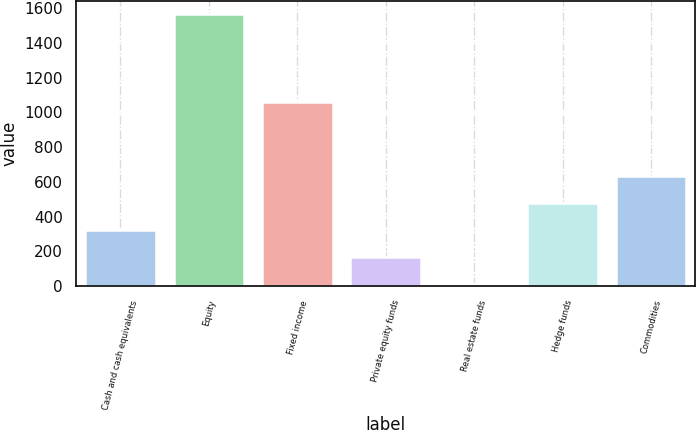<chart> <loc_0><loc_0><loc_500><loc_500><bar_chart><fcel>Cash and cash equivalents<fcel>Equity<fcel>Fixed income<fcel>Private equity funds<fcel>Real estate funds<fcel>Hedge funds<fcel>Commodities<nl><fcel>321<fcel>1565<fcel>1060<fcel>165.5<fcel>10<fcel>476.5<fcel>632<nl></chart> 